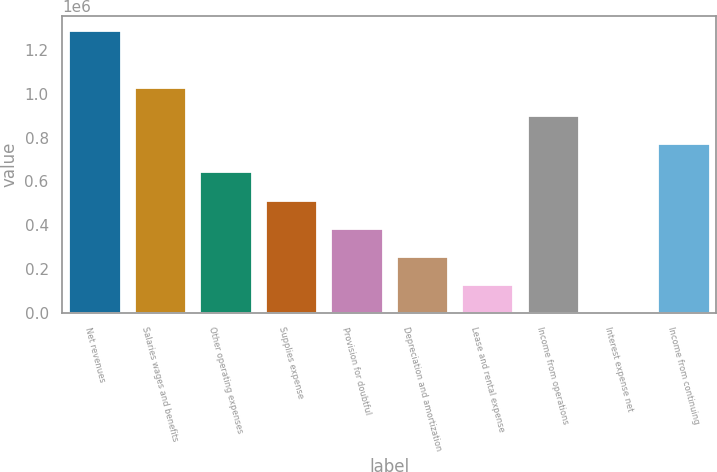Convert chart. <chart><loc_0><loc_0><loc_500><loc_500><bar_chart><fcel>Net revenues<fcel>Salaries wages and benefits<fcel>Other operating expenses<fcel>Supplies expense<fcel>Provision for doubtful<fcel>Depreciation and amortization<fcel>Lease and rental expense<fcel>Income from operations<fcel>Interest expense net<fcel>Income from continuing<nl><fcel>1.29161e+06<fcel>1.03333e+06<fcel>645910<fcel>516769<fcel>387629<fcel>258489<fcel>129349<fcel>904190<fcel>209<fcel>775050<nl></chart> 